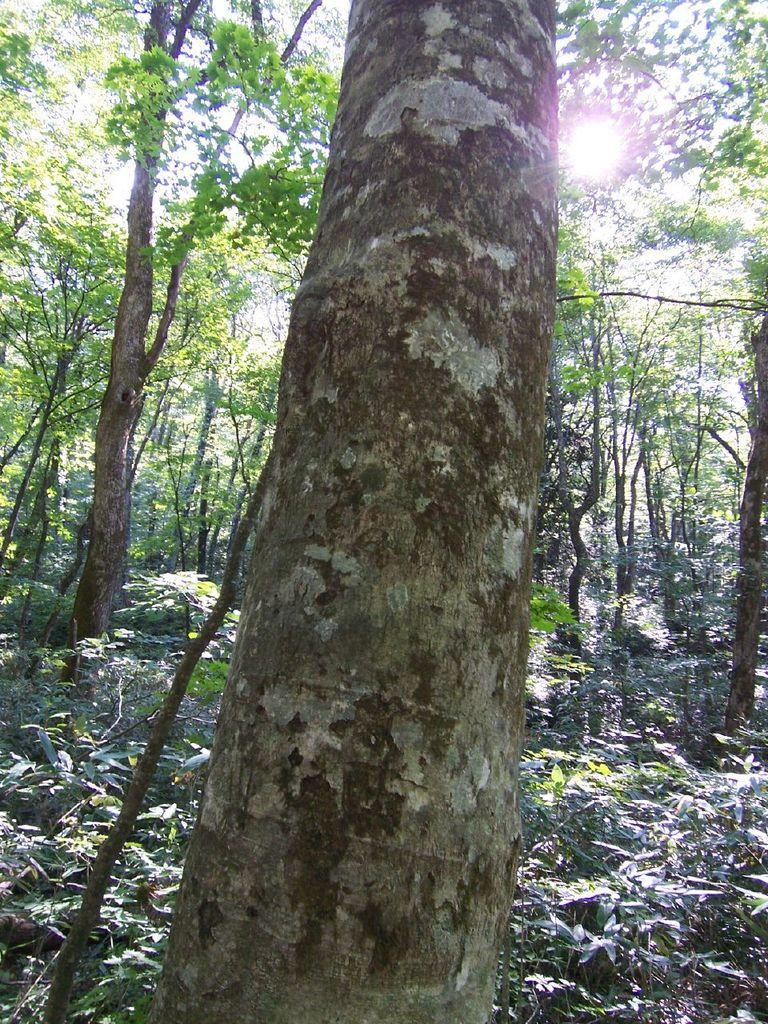What type of vegetation can be seen in the image? There are trees in the image. What celestial body is visible in the image? The sun is visible in the image. What object is located in front of the trees? There is a trunk in front of the trees. Where is the basin located in the image? There is no basin present in the image. What type of basket can be seen hanging from the trees in the image? There are no baskets present in the image, and the trees do not have any hanging objects. 